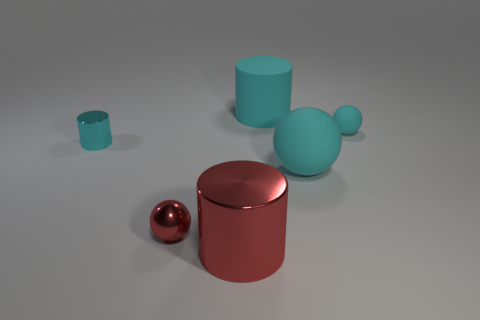There is a cyan metal cylinder; what number of cyan shiny things are in front of it?
Provide a short and direct response. 0. What color is the tiny shiny thing that is the same shape as the large metallic object?
Your answer should be compact. Cyan. What is the object that is to the right of the small cylinder and left of the large red metal cylinder made of?
Offer a very short reply. Metal. Does the shiny cylinder that is left of the red shiny cylinder have the same size as the big cyan cylinder?
Make the answer very short. No. What material is the red cylinder?
Make the answer very short. Metal. There is a cylinder that is in front of the tiny cyan metallic object; what color is it?
Offer a very short reply. Red. How many big objects are either cyan metallic cylinders or red things?
Provide a short and direct response. 1. Does the tiny sphere to the right of the red metallic cylinder have the same color as the cylinder right of the large red cylinder?
Your answer should be compact. Yes. How many other objects are there of the same color as the big rubber ball?
Give a very brief answer. 3. What number of red objects are shiny cylinders or big matte things?
Your answer should be very brief. 1. 